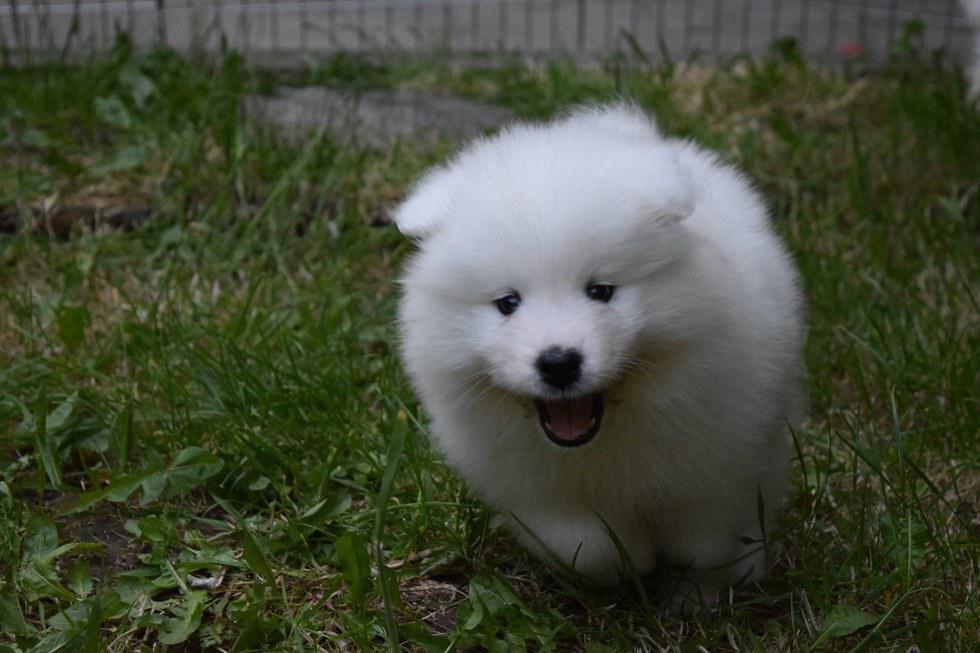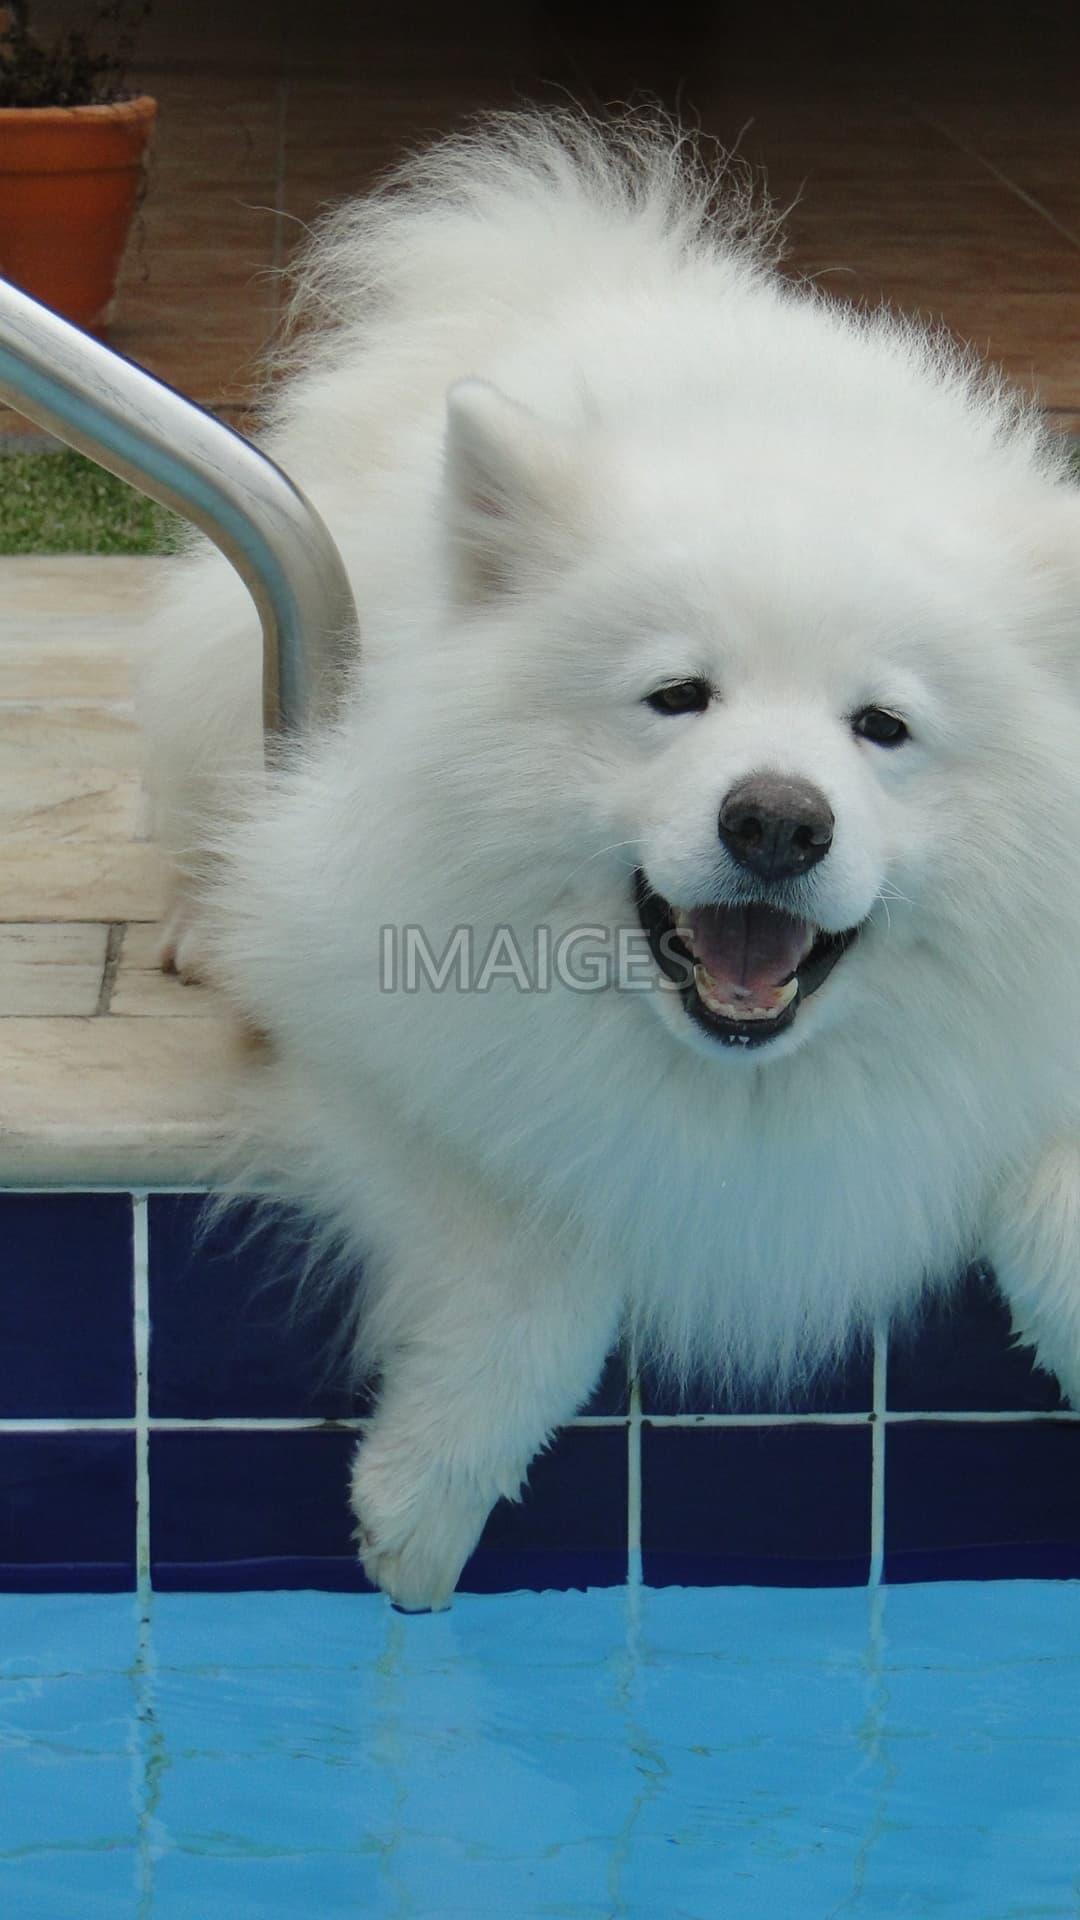The first image is the image on the left, the second image is the image on the right. For the images displayed, is the sentence "There is at least one dog that is not playing or swimming in the water." factually correct? Answer yes or no. Yes. The first image is the image on the left, the second image is the image on the right. Considering the images on both sides, is "The dog in the left image is standing on the ground; he is not in the water." valid? Answer yes or no. Yes. 